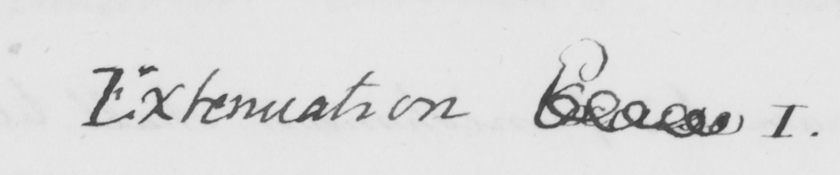Please transcribe the handwritten text in this image. Extenuation Excuse I . 